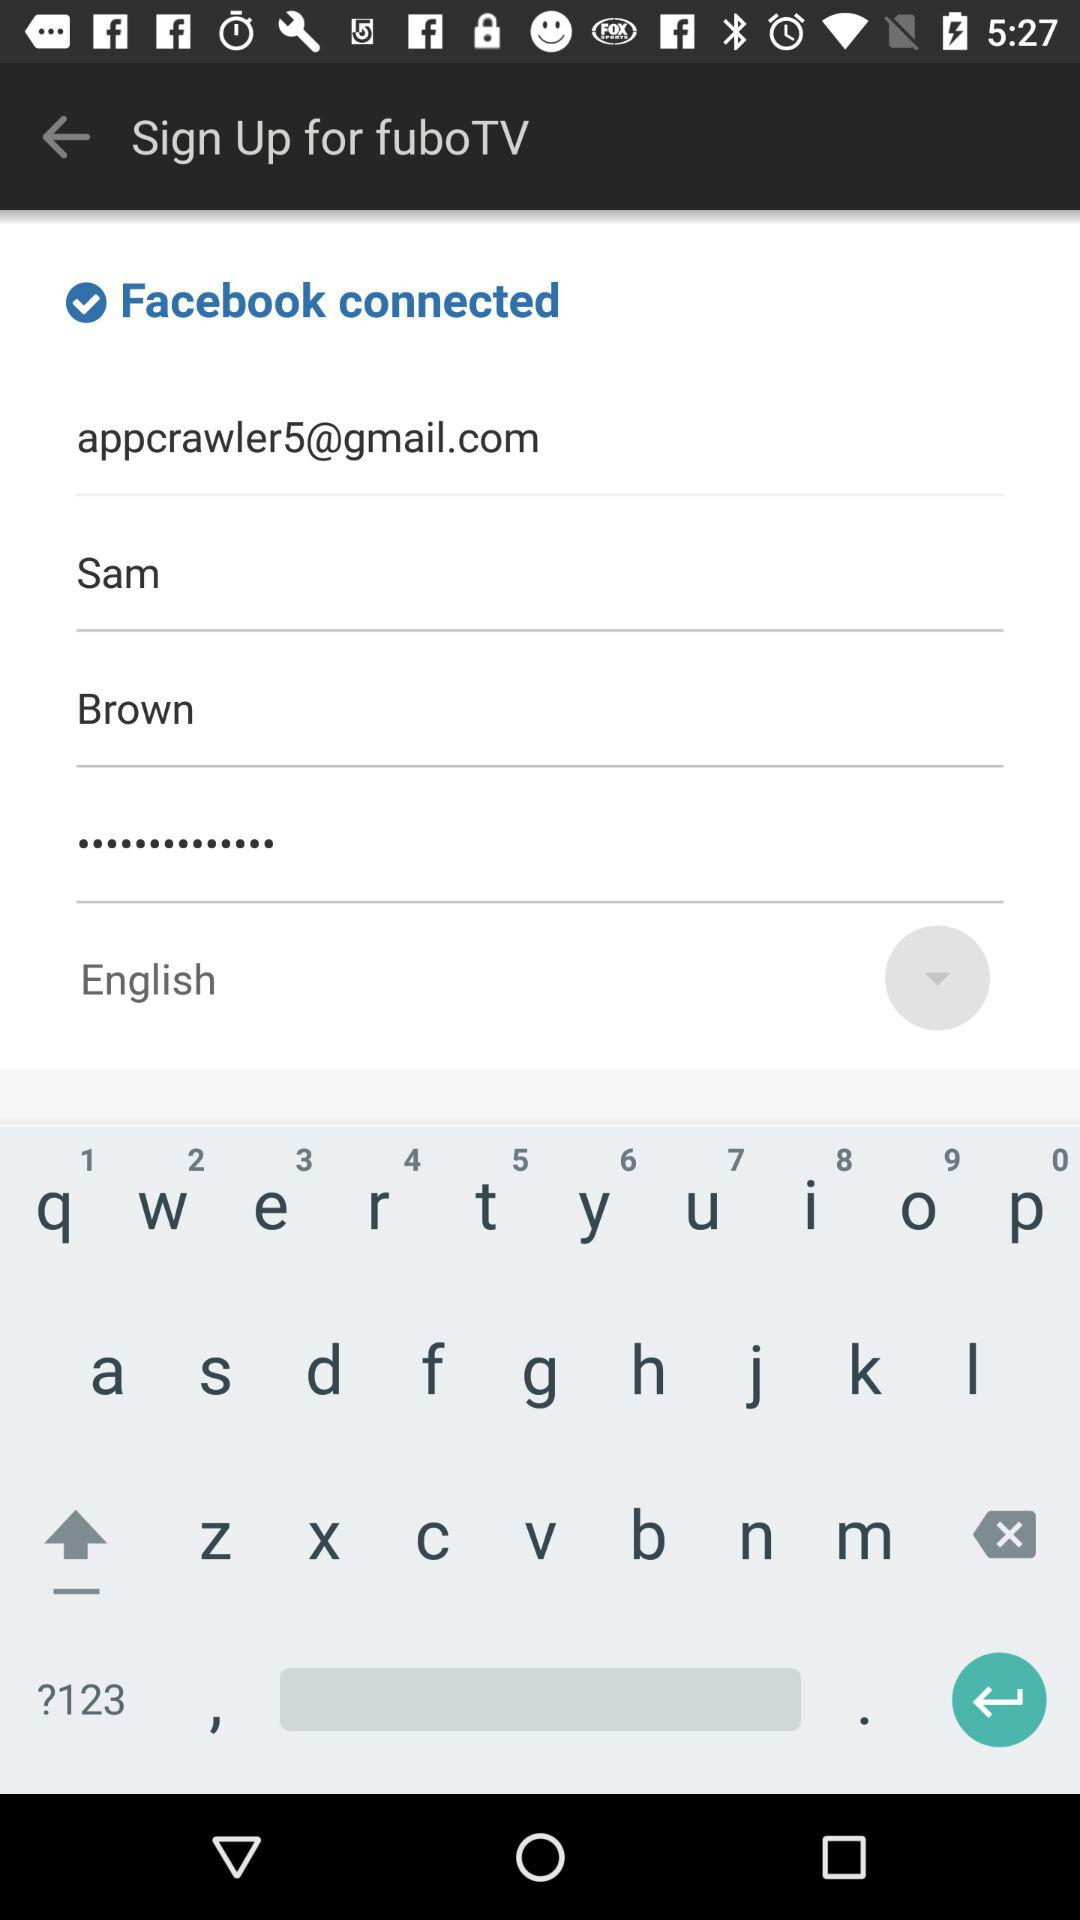What is the user name? The user name is Sam Brown. 